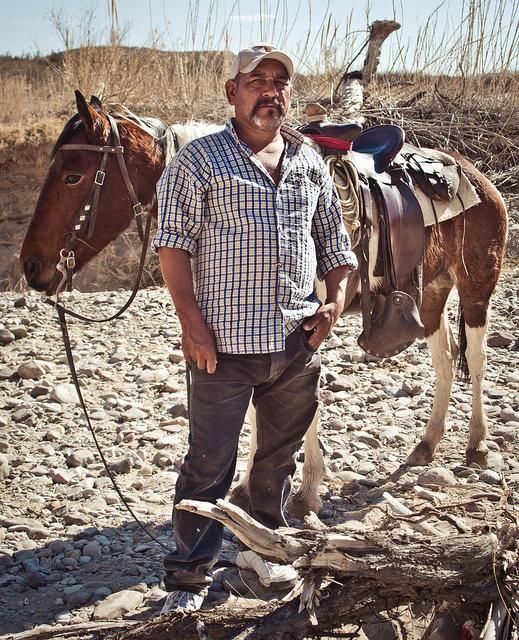Who is taking the picture?
Give a very brief answer. Photographer. Is the man in the picture happy?
Answer briefly. No. What is on the horse?
Write a very short answer. Saddle. 